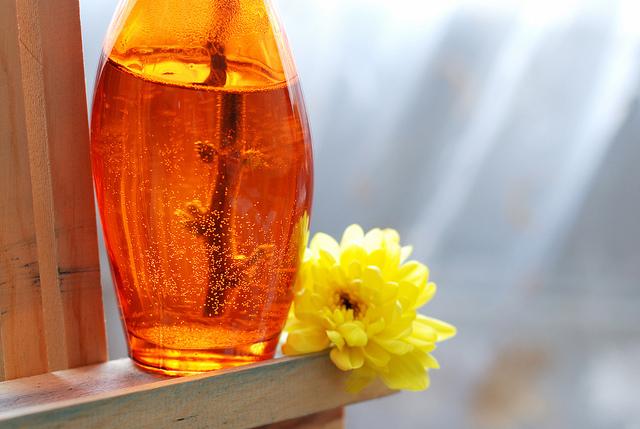What color is the flower?
Write a very short answer. Yellow. Is the water in the vase fresh?
Quick response, please. No. What is the vase made of?
Write a very short answer. Glass. 